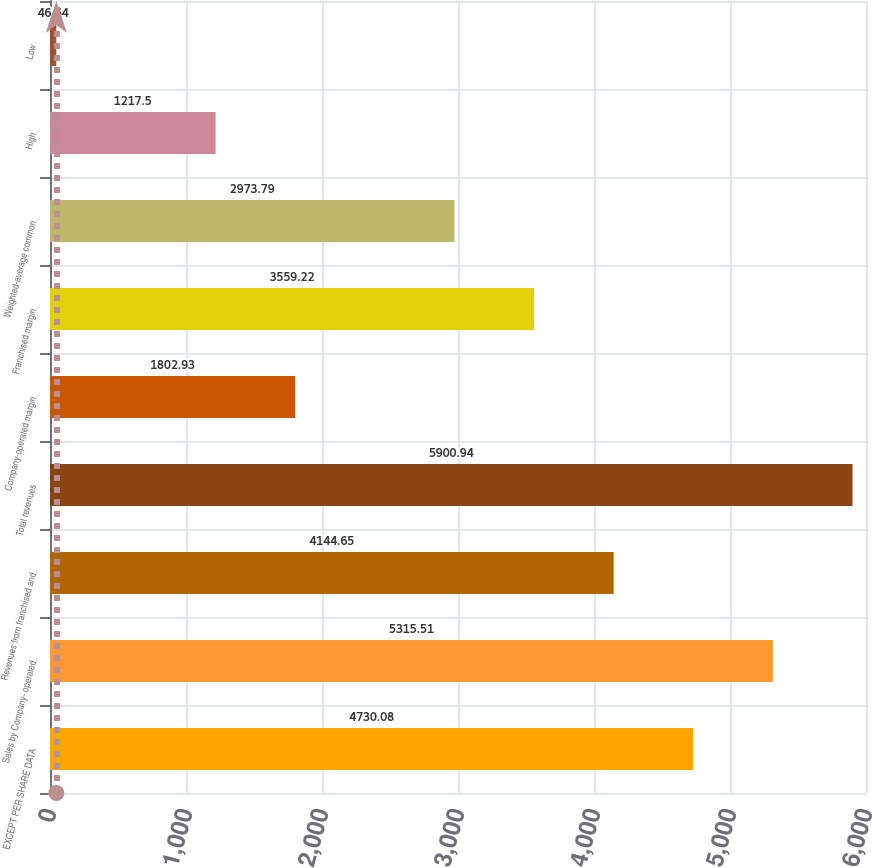Convert chart. <chart><loc_0><loc_0><loc_500><loc_500><bar_chart><fcel>EXCEPT PER SHARE DATA<fcel>Sales by Company- operated<fcel>Revenues from franchised and<fcel>Total revenues<fcel>Company-operated margin<fcel>Franchised margin<fcel>Weighted-average common<fcel>High<fcel>Low<nl><fcel>4730.08<fcel>5315.51<fcel>4144.65<fcel>5900.94<fcel>1802.93<fcel>3559.22<fcel>2973.79<fcel>1217.5<fcel>46.64<nl></chart> 